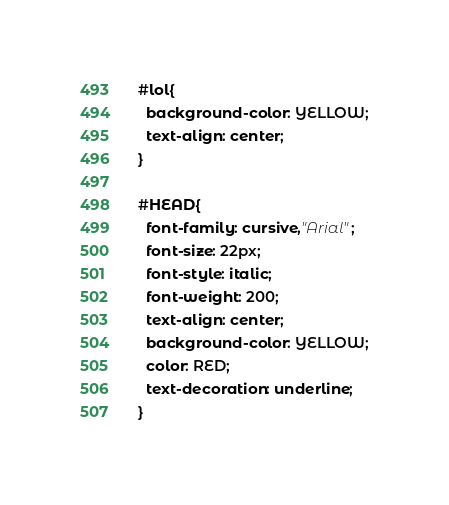Convert code to text. <code><loc_0><loc_0><loc_500><loc_500><_CSS_>
#lol{
  background-color: YELLOW;
  text-align: center;
}

#HEAD{
  font-family: cursive,"Arial";
  font-size: 22px;
  font-style: italic;
  font-weight: 200;
  text-align: center;
  background-color: YELLOW;
  color: RED;
  text-decoration: underline;
}
</code> 